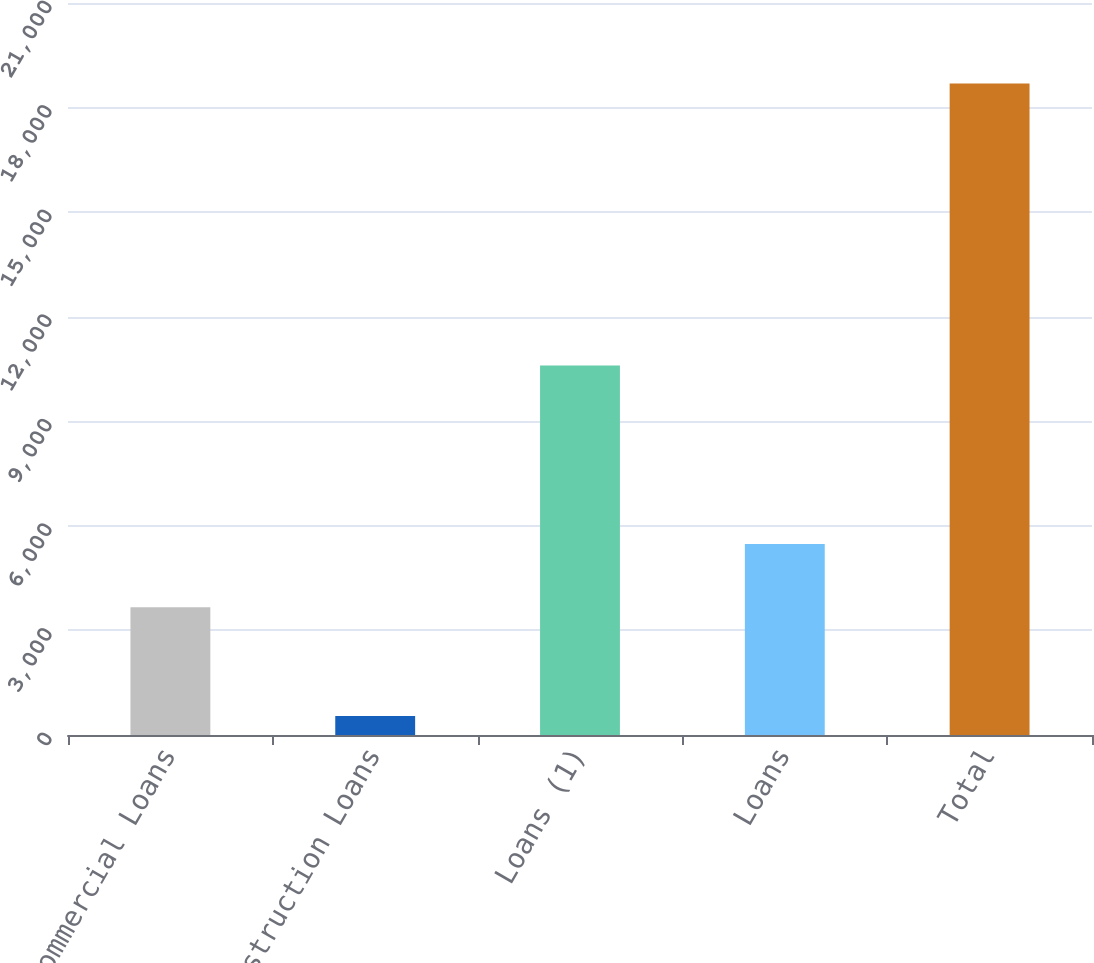Convert chart to OTSL. <chart><loc_0><loc_0><loc_500><loc_500><bar_chart><fcel>Commercial Loans<fcel>Construction Loans<fcel>Loans (1)<fcel>Loans<fcel>Total<nl><fcel>3663<fcel>548<fcel>10603<fcel>5477.6<fcel>18694<nl></chart> 